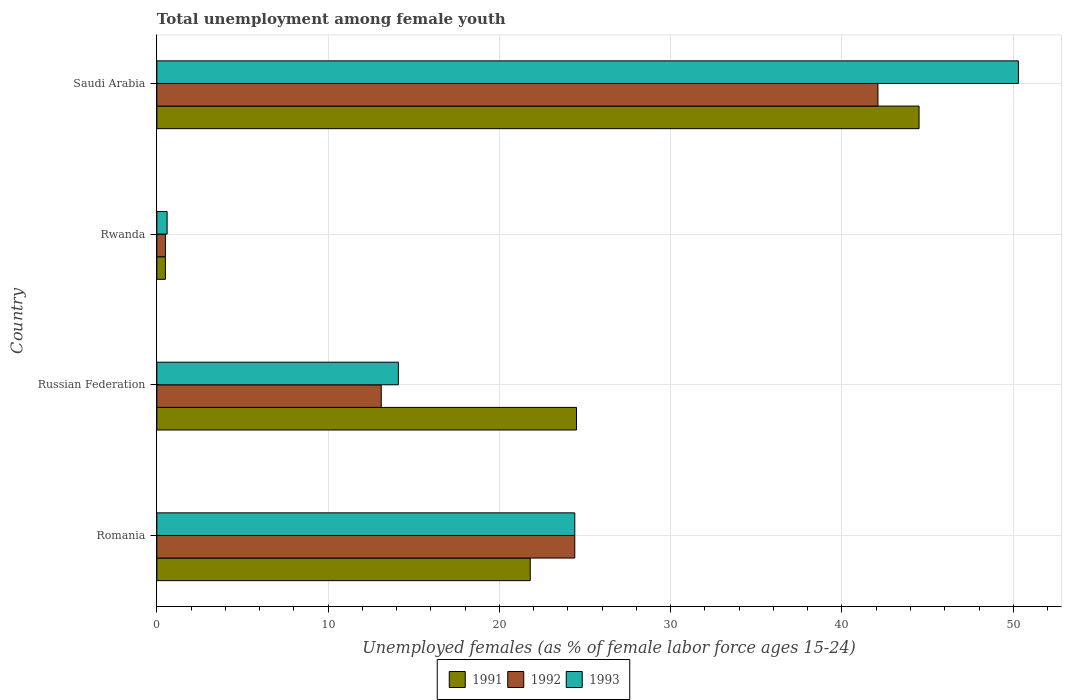How many different coloured bars are there?
Ensure brevity in your answer.  3. Are the number of bars per tick equal to the number of legend labels?
Give a very brief answer. Yes. Are the number of bars on each tick of the Y-axis equal?
Offer a terse response. Yes. How many bars are there on the 4th tick from the top?
Ensure brevity in your answer.  3. How many bars are there on the 2nd tick from the bottom?
Your response must be concise. 3. What is the label of the 1st group of bars from the top?
Keep it short and to the point. Saudi Arabia. In how many cases, is the number of bars for a given country not equal to the number of legend labels?
Make the answer very short. 0. What is the percentage of unemployed females in in 1991 in Rwanda?
Offer a very short reply. 0.5. Across all countries, what is the maximum percentage of unemployed females in in 1991?
Provide a short and direct response. 44.5. In which country was the percentage of unemployed females in in 1992 maximum?
Ensure brevity in your answer.  Saudi Arabia. In which country was the percentage of unemployed females in in 1991 minimum?
Your answer should be very brief. Rwanda. What is the total percentage of unemployed females in in 1993 in the graph?
Provide a short and direct response. 89.4. What is the difference between the percentage of unemployed females in in 1992 in Rwanda and that in Saudi Arabia?
Offer a terse response. -41.6. What is the difference between the percentage of unemployed females in in 1993 in Romania and the percentage of unemployed females in in 1992 in Russian Federation?
Make the answer very short. 11.3. What is the average percentage of unemployed females in in 1991 per country?
Provide a succinct answer. 22.82. What is the difference between the percentage of unemployed females in in 1993 and percentage of unemployed females in in 1991 in Rwanda?
Your response must be concise. 0.1. Is the percentage of unemployed females in in 1992 in Russian Federation less than that in Rwanda?
Your answer should be very brief. No. What is the difference between the highest and the second highest percentage of unemployed females in in 1992?
Give a very brief answer. 17.7. What is the difference between the highest and the lowest percentage of unemployed females in in 1992?
Provide a short and direct response. 41.6. Is the sum of the percentage of unemployed females in in 1992 in Russian Federation and Rwanda greater than the maximum percentage of unemployed females in in 1993 across all countries?
Keep it short and to the point. No. What does the 1st bar from the top in Romania represents?
Offer a very short reply. 1993. How many countries are there in the graph?
Give a very brief answer. 4. Does the graph contain any zero values?
Provide a short and direct response. No. Does the graph contain grids?
Your answer should be compact. Yes. What is the title of the graph?
Offer a very short reply. Total unemployment among female youth. Does "1989" appear as one of the legend labels in the graph?
Your response must be concise. No. What is the label or title of the X-axis?
Your answer should be very brief. Unemployed females (as % of female labor force ages 15-24). What is the label or title of the Y-axis?
Provide a short and direct response. Country. What is the Unemployed females (as % of female labor force ages 15-24) in 1991 in Romania?
Provide a succinct answer. 21.8. What is the Unemployed females (as % of female labor force ages 15-24) of 1992 in Romania?
Offer a very short reply. 24.4. What is the Unemployed females (as % of female labor force ages 15-24) of 1993 in Romania?
Provide a succinct answer. 24.4. What is the Unemployed females (as % of female labor force ages 15-24) in 1991 in Russian Federation?
Offer a terse response. 24.5. What is the Unemployed females (as % of female labor force ages 15-24) in 1992 in Russian Federation?
Ensure brevity in your answer.  13.1. What is the Unemployed females (as % of female labor force ages 15-24) of 1993 in Russian Federation?
Offer a very short reply. 14.1. What is the Unemployed females (as % of female labor force ages 15-24) in 1991 in Rwanda?
Provide a succinct answer. 0.5. What is the Unemployed females (as % of female labor force ages 15-24) in 1992 in Rwanda?
Ensure brevity in your answer.  0.5. What is the Unemployed females (as % of female labor force ages 15-24) in 1993 in Rwanda?
Make the answer very short. 0.6. What is the Unemployed females (as % of female labor force ages 15-24) in 1991 in Saudi Arabia?
Keep it short and to the point. 44.5. What is the Unemployed females (as % of female labor force ages 15-24) of 1992 in Saudi Arabia?
Provide a succinct answer. 42.1. What is the Unemployed females (as % of female labor force ages 15-24) in 1993 in Saudi Arabia?
Offer a terse response. 50.3. Across all countries, what is the maximum Unemployed females (as % of female labor force ages 15-24) in 1991?
Offer a terse response. 44.5. Across all countries, what is the maximum Unemployed females (as % of female labor force ages 15-24) of 1992?
Offer a terse response. 42.1. Across all countries, what is the maximum Unemployed females (as % of female labor force ages 15-24) in 1993?
Your answer should be very brief. 50.3. Across all countries, what is the minimum Unemployed females (as % of female labor force ages 15-24) of 1993?
Make the answer very short. 0.6. What is the total Unemployed females (as % of female labor force ages 15-24) of 1991 in the graph?
Your answer should be compact. 91.3. What is the total Unemployed females (as % of female labor force ages 15-24) of 1992 in the graph?
Provide a succinct answer. 80.1. What is the total Unemployed females (as % of female labor force ages 15-24) in 1993 in the graph?
Provide a short and direct response. 89.4. What is the difference between the Unemployed females (as % of female labor force ages 15-24) of 1991 in Romania and that in Rwanda?
Your answer should be very brief. 21.3. What is the difference between the Unemployed females (as % of female labor force ages 15-24) in 1992 in Romania and that in Rwanda?
Ensure brevity in your answer.  23.9. What is the difference between the Unemployed females (as % of female labor force ages 15-24) of 1993 in Romania and that in Rwanda?
Provide a succinct answer. 23.8. What is the difference between the Unemployed females (as % of female labor force ages 15-24) in 1991 in Romania and that in Saudi Arabia?
Offer a very short reply. -22.7. What is the difference between the Unemployed females (as % of female labor force ages 15-24) of 1992 in Romania and that in Saudi Arabia?
Your answer should be compact. -17.7. What is the difference between the Unemployed females (as % of female labor force ages 15-24) in 1993 in Romania and that in Saudi Arabia?
Keep it short and to the point. -25.9. What is the difference between the Unemployed females (as % of female labor force ages 15-24) of 1991 in Russian Federation and that in Rwanda?
Offer a very short reply. 24. What is the difference between the Unemployed females (as % of female labor force ages 15-24) in 1992 in Russian Federation and that in Rwanda?
Ensure brevity in your answer.  12.6. What is the difference between the Unemployed females (as % of female labor force ages 15-24) in 1993 in Russian Federation and that in Rwanda?
Ensure brevity in your answer.  13.5. What is the difference between the Unemployed females (as % of female labor force ages 15-24) in 1992 in Russian Federation and that in Saudi Arabia?
Your answer should be compact. -29. What is the difference between the Unemployed females (as % of female labor force ages 15-24) of 1993 in Russian Federation and that in Saudi Arabia?
Offer a very short reply. -36.2. What is the difference between the Unemployed females (as % of female labor force ages 15-24) in 1991 in Rwanda and that in Saudi Arabia?
Your answer should be very brief. -44. What is the difference between the Unemployed females (as % of female labor force ages 15-24) in 1992 in Rwanda and that in Saudi Arabia?
Your answer should be compact. -41.6. What is the difference between the Unemployed females (as % of female labor force ages 15-24) of 1993 in Rwanda and that in Saudi Arabia?
Ensure brevity in your answer.  -49.7. What is the difference between the Unemployed females (as % of female labor force ages 15-24) of 1991 in Romania and the Unemployed females (as % of female labor force ages 15-24) of 1993 in Russian Federation?
Offer a very short reply. 7.7. What is the difference between the Unemployed females (as % of female labor force ages 15-24) of 1992 in Romania and the Unemployed females (as % of female labor force ages 15-24) of 1993 in Russian Federation?
Your answer should be compact. 10.3. What is the difference between the Unemployed females (as % of female labor force ages 15-24) of 1991 in Romania and the Unemployed females (as % of female labor force ages 15-24) of 1992 in Rwanda?
Your answer should be compact. 21.3. What is the difference between the Unemployed females (as % of female labor force ages 15-24) in 1991 in Romania and the Unemployed females (as % of female labor force ages 15-24) in 1993 in Rwanda?
Provide a short and direct response. 21.2. What is the difference between the Unemployed females (as % of female labor force ages 15-24) of 1992 in Romania and the Unemployed females (as % of female labor force ages 15-24) of 1993 in Rwanda?
Your response must be concise. 23.8. What is the difference between the Unemployed females (as % of female labor force ages 15-24) of 1991 in Romania and the Unemployed females (as % of female labor force ages 15-24) of 1992 in Saudi Arabia?
Offer a very short reply. -20.3. What is the difference between the Unemployed females (as % of female labor force ages 15-24) of 1991 in Romania and the Unemployed females (as % of female labor force ages 15-24) of 1993 in Saudi Arabia?
Keep it short and to the point. -28.5. What is the difference between the Unemployed females (as % of female labor force ages 15-24) of 1992 in Romania and the Unemployed females (as % of female labor force ages 15-24) of 1993 in Saudi Arabia?
Provide a short and direct response. -25.9. What is the difference between the Unemployed females (as % of female labor force ages 15-24) in 1991 in Russian Federation and the Unemployed females (as % of female labor force ages 15-24) in 1993 in Rwanda?
Give a very brief answer. 23.9. What is the difference between the Unemployed females (as % of female labor force ages 15-24) of 1992 in Russian Federation and the Unemployed females (as % of female labor force ages 15-24) of 1993 in Rwanda?
Your response must be concise. 12.5. What is the difference between the Unemployed females (as % of female labor force ages 15-24) in 1991 in Russian Federation and the Unemployed females (as % of female labor force ages 15-24) in 1992 in Saudi Arabia?
Provide a short and direct response. -17.6. What is the difference between the Unemployed females (as % of female labor force ages 15-24) of 1991 in Russian Federation and the Unemployed females (as % of female labor force ages 15-24) of 1993 in Saudi Arabia?
Your response must be concise. -25.8. What is the difference between the Unemployed females (as % of female labor force ages 15-24) of 1992 in Russian Federation and the Unemployed females (as % of female labor force ages 15-24) of 1993 in Saudi Arabia?
Offer a very short reply. -37.2. What is the difference between the Unemployed females (as % of female labor force ages 15-24) of 1991 in Rwanda and the Unemployed females (as % of female labor force ages 15-24) of 1992 in Saudi Arabia?
Offer a very short reply. -41.6. What is the difference between the Unemployed females (as % of female labor force ages 15-24) of 1991 in Rwanda and the Unemployed females (as % of female labor force ages 15-24) of 1993 in Saudi Arabia?
Provide a short and direct response. -49.8. What is the difference between the Unemployed females (as % of female labor force ages 15-24) of 1992 in Rwanda and the Unemployed females (as % of female labor force ages 15-24) of 1993 in Saudi Arabia?
Provide a succinct answer. -49.8. What is the average Unemployed females (as % of female labor force ages 15-24) of 1991 per country?
Offer a very short reply. 22.82. What is the average Unemployed females (as % of female labor force ages 15-24) of 1992 per country?
Keep it short and to the point. 20.02. What is the average Unemployed females (as % of female labor force ages 15-24) of 1993 per country?
Provide a short and direct response. 22.35. What is the difference between the Unemployed females (as % of female labor force ages 15-24) in 1992 and Unemployed females (as % of female labor force ages 15-24) in 1993 in Romania?
Ensure brevity in your answer.  0. What is the difference between the Unemployed females (as % of female labor force ages 15-24) in 1992 and Unemployed females (as % of female labor force ages 15-24) in 1993 in Russian Federation?
Offer a very short reply. -1. What is the difference between the Unemployed females (as % of female labor force ages 15-24) of 1991 and Unemployed females (as % of female labor force ages 15-24) of 1992 in Rwanda?
Give a very brief answer. 0. What is the difference between the Unemployed females (as % of female labor force ages 15-24) in 1991 and Unemployed females (as % of female labor force ages 15-24) in 1993 in Rwanda?
Give a very brief answer. -0.1. What is the difference between the Unemployed females (as % of female labor force ages 15-24) of 1991 and Unemployed females (as % of female labor force ages 15-24) of 1992 in Saudi Arabia?
Make the answer very short. 2.4. What is the difference between the Unemployed females (as % of female labor force ages 15-24) in 1992 and Unemployed females (as % of female labor force ages 15-24) in 1993 in Saudi Arabia?
Give a very brief answer. -8.2. What is the ratio of the Unemployed females (as % of female labor force ages 15-24) of 1991 in Romania to that in Russian Federation?
Your answer should be compact. 0.89. What is the ratio of the Unemployed females (as % of female labor force ages 15-24) in 1992 in Romania to that in Russian Federation?
Your response must be concise. 1.86. What is the ratio of the Unemployed females (as % of female labor force ages 15-24) of 1993 in Romania to that in Russian Federation?
Your response must be concise. 1.73. What is the ratio of the Unemployed females (as % of female labor force ages 15-24) in 1991 in Romania to that in Rwanda?
Your response must be concise. 43.6. What is the ratio of the Unemployed females (as % of female labor force ages 15-24) of 1992 in Romania to that in Rwanda?
Offer a terse response. 48.8. What is the ratio of the Unemployed females (as % of female labor force ages 15-24) of 1993 in Romania to that in Rwanda?
Provide a short and direct response. 40.67. What is the ratio of the Unemployed females (as % of female labor force ages 15-24) of 1991 in Romania to that in Saudi Arabia?
Provide a short and direct response. 0.49. What is the ratio of the Unemployed females (as % of female labor force ages 15-24) of 1992 in Romania to that in Saudi Arabia?
Give a very brief answer. 0.58. What is the ratio of the Unemployed females (as % of female labor force ages 15-24) in 1993 in Romania to that in Saudi Arabia?
Ensure brevity in your answer.  0.49. What is the ratio of the Unemployed females (as % of female labor force ages 15-24) of 1991 in Russian Federation to that in Rwanda?
Your response must be concise. 49. What is the ratio of the Unemployed females (as % of female labor force ages 15-24) in 1992 in Russian Federation to that in Rwanda?
Give a very brief answer. 26.2. What is the ratio of the Unemployed females (as % of female labor force ages 15-24) in 1993 in Russian Federation to that in Rwanda?
Offer a terse response. 23.5. What is the ratio of the Unemployed females (as % of female labor force ages 15-24) in 1991 in Russian Federation to that in Saudi Arabia?
Your answer should be very brief. 0.55. What is the ratio of the Unemployed females (as % of female labor force ages 15-24) of 1992 in Russian Federation to that in Saudi Arabia?
Make the answer very short. 0.31. What is the ratio of the Unemployed females (as % of female labor force ages 15-24) in 1993 in Russian Federation to that in Saudi Arabia?
Keep it short and to the point. 0.28. What is the ratio of the Unemployed females (as % of female labor force ages 15-24) in 1991 in Rwanda to that in Saudi Arabia?
Give a very brief answer. 0.01. What is the ratio of the Unemployed females (as % of female labor force ages 15-24) in 1992 in Rwanda to that in Saudi Arabia?
Your answer should be very brief. 0.01. What is the ratio of the Unemployed females (as % of female labor force ages 15-24) of 1993 in Rwanda to that in Saudi Arabia?
Your answer should be compact. 0.01. What is the difference between the highest and the second highest Unemployed females (as % of female labor force ages 15-24) in 1993?
Your answer should be very brief. 25.9. What is the difference between the highest and the lowest Unemployed females (as % of female labor force ages 15-24) in 1992?
Your answer should be compact. 41.6. What is the difference between the highest and the lowest Unemployed females (as % of female labor force ages 15-24) of 1993?
Keep it short and to the point. 49.7. 